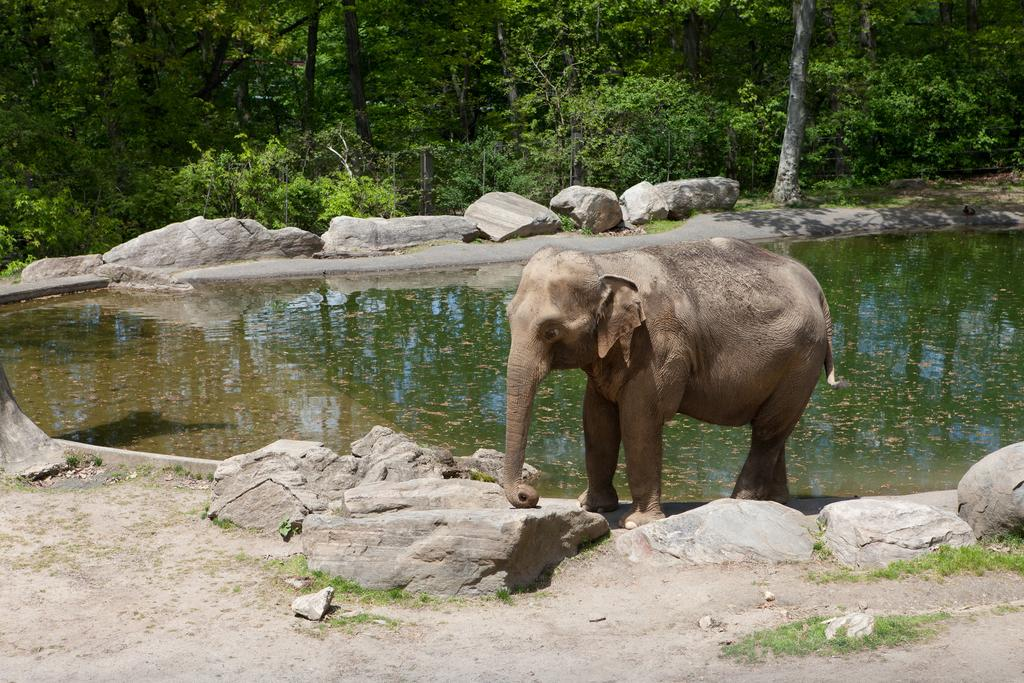What type of vegetation can be seen towards the top of the image? There are trees towards the top of the image. What natural element is visible in the image? There is water visible in the image. What type of geological formation can be seen in the image? There are rocks in the image. What animal is present in the image? There is an elephant in the image. What type of ground cover is present in the image? There is grass in the image. What type of material is present on the ground in the image? There are stones on the ground in the image. What type of can is visible in the image? There is no can present in the image. How does the elephant transport goods in the image? The image does not show the elephant transporting goods. 